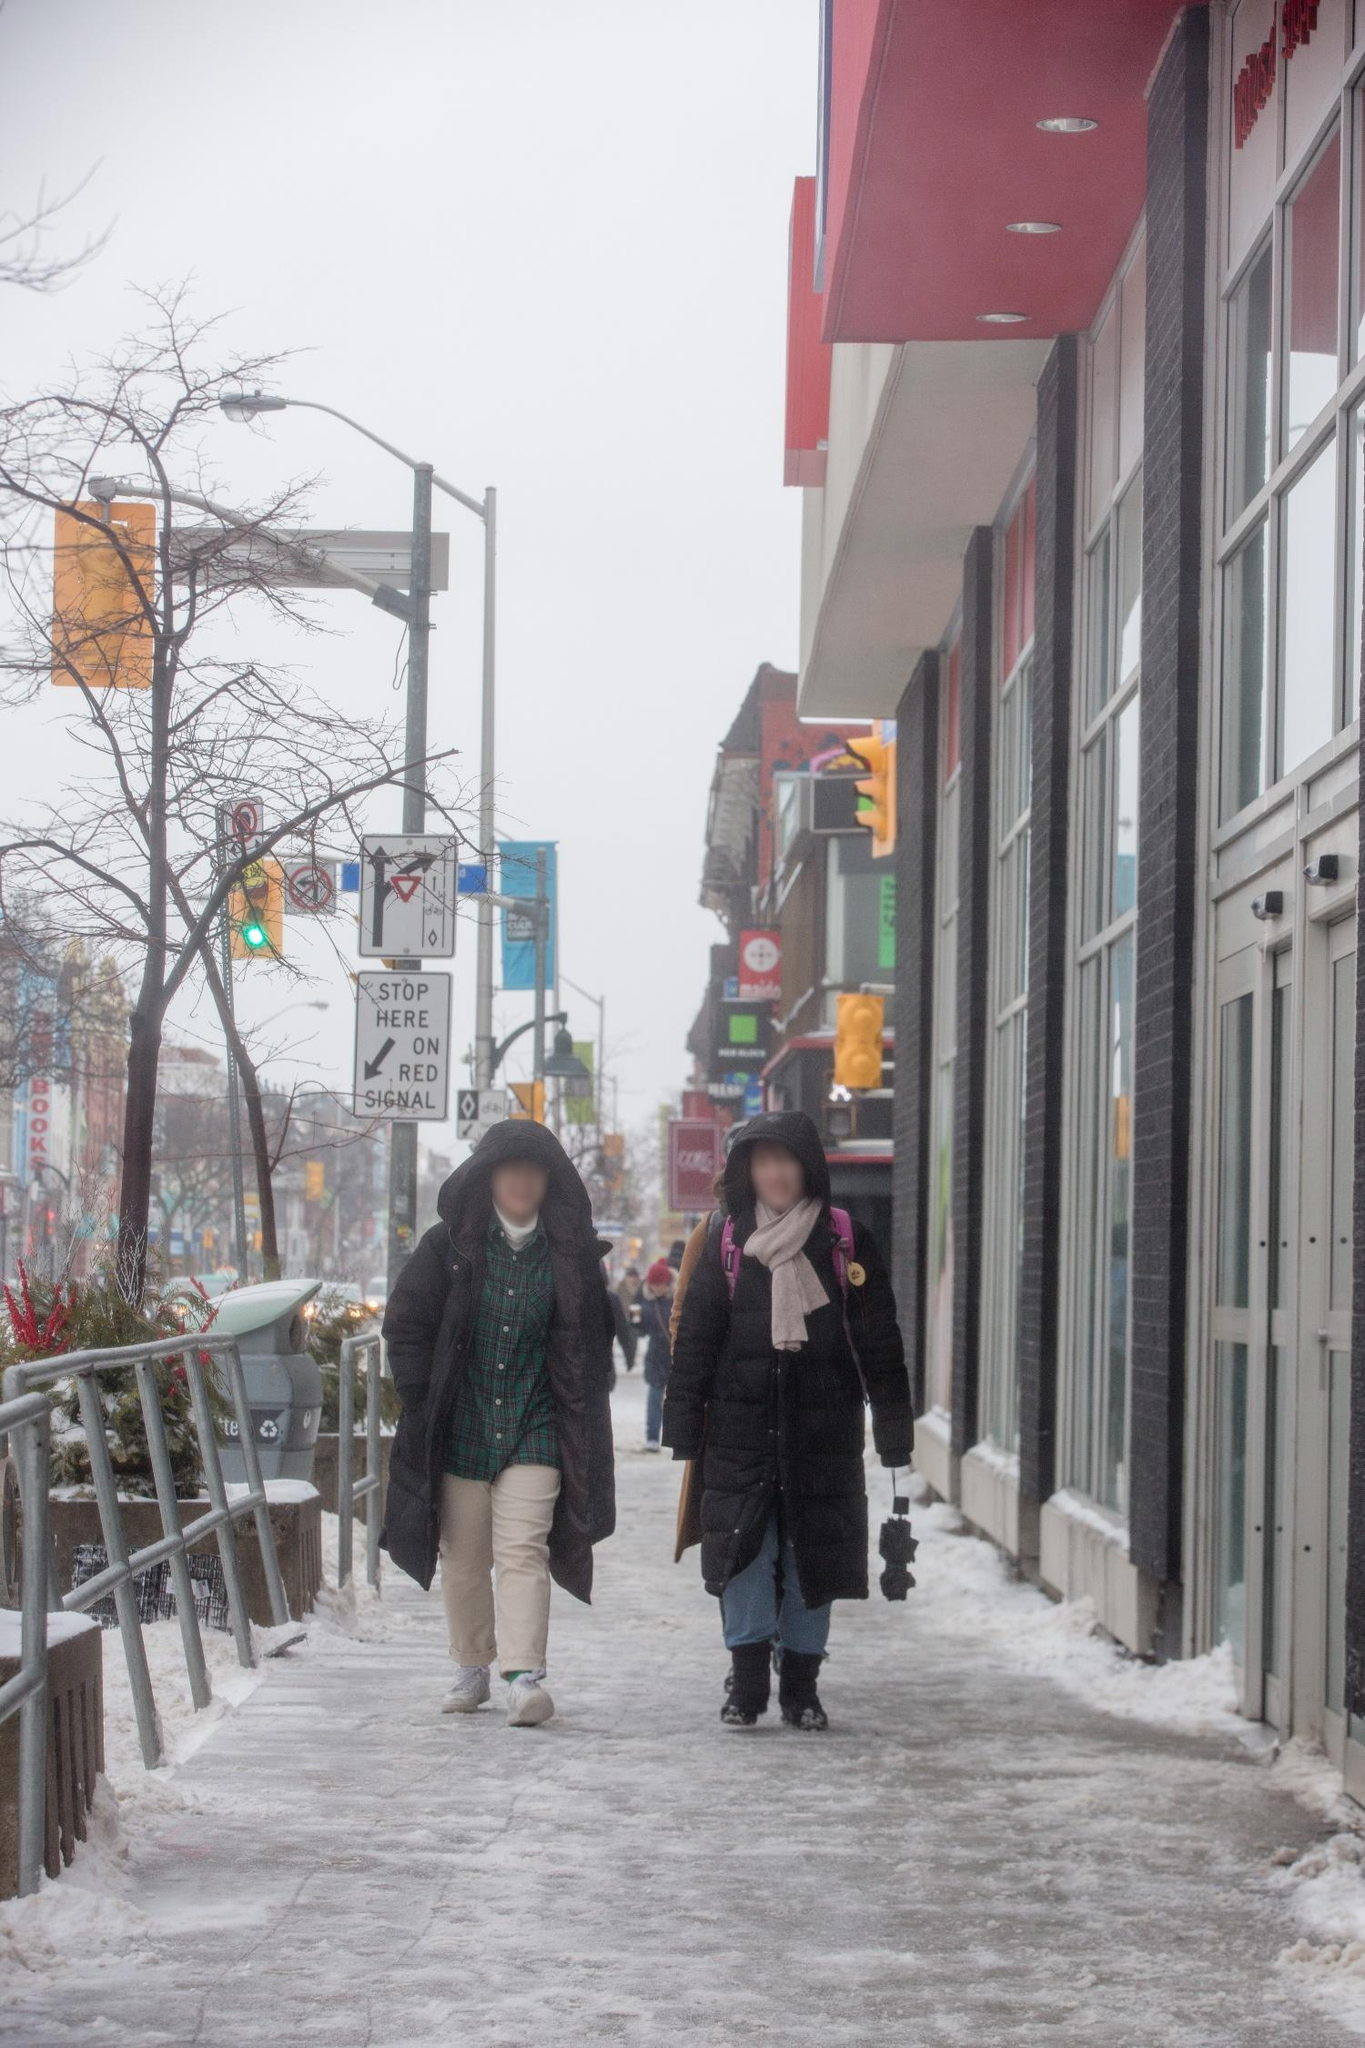What could be the next moment in this realistic scene? In the next moment, the two friends might pause under the awning of the red building to brush off the snow from their coats. They could decide to step into a nearby café they remember from their childhood for a warm drink. Inside, they'd find the cozy atmosphere a perfect counter to the outside chill, exchanging smiles as they order hot cocoa or coffee and continue their conversation, savoring the warmth and comfort of familiar surroundings.  Describe a funny scenario that could happen right now in this image. As they walk along the icy sidewalk, one of the friends could slip and almost fall, but instead, they perform an accidental, yet spectacular, save that looks almost like a dance move. This unexpected moment sends them both into fits of laughter. They catch the amused and friendly looks from others around them, sparking brief, cheerful interactions and making the cold, gray day a little brighter with shared humor. 